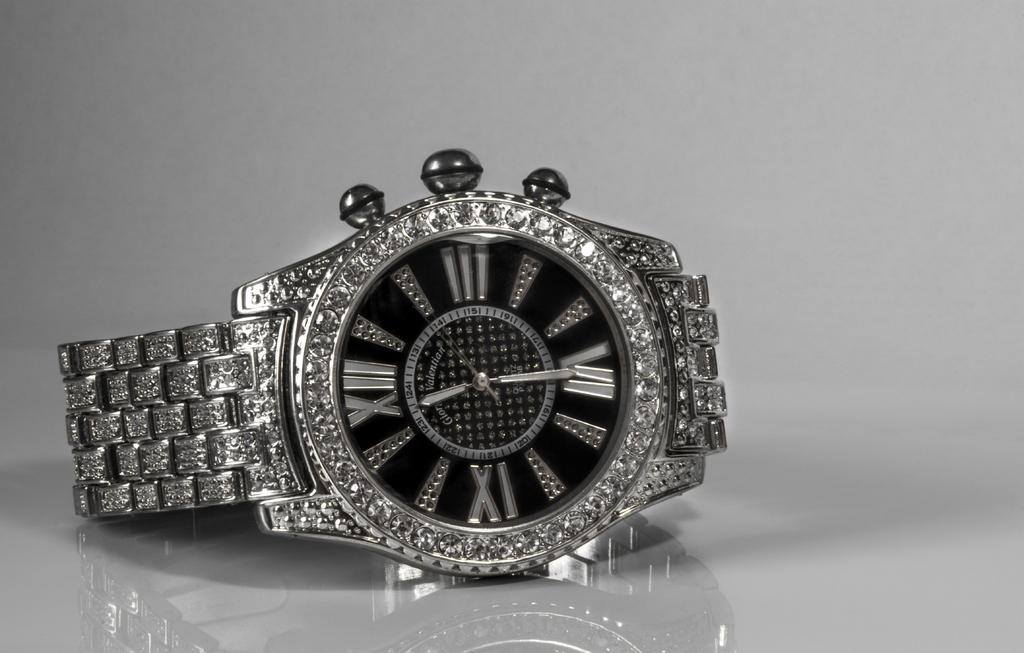<image>
Summarize the visual content of the image. A diamond encrusted watch shows the time as 11:29. 